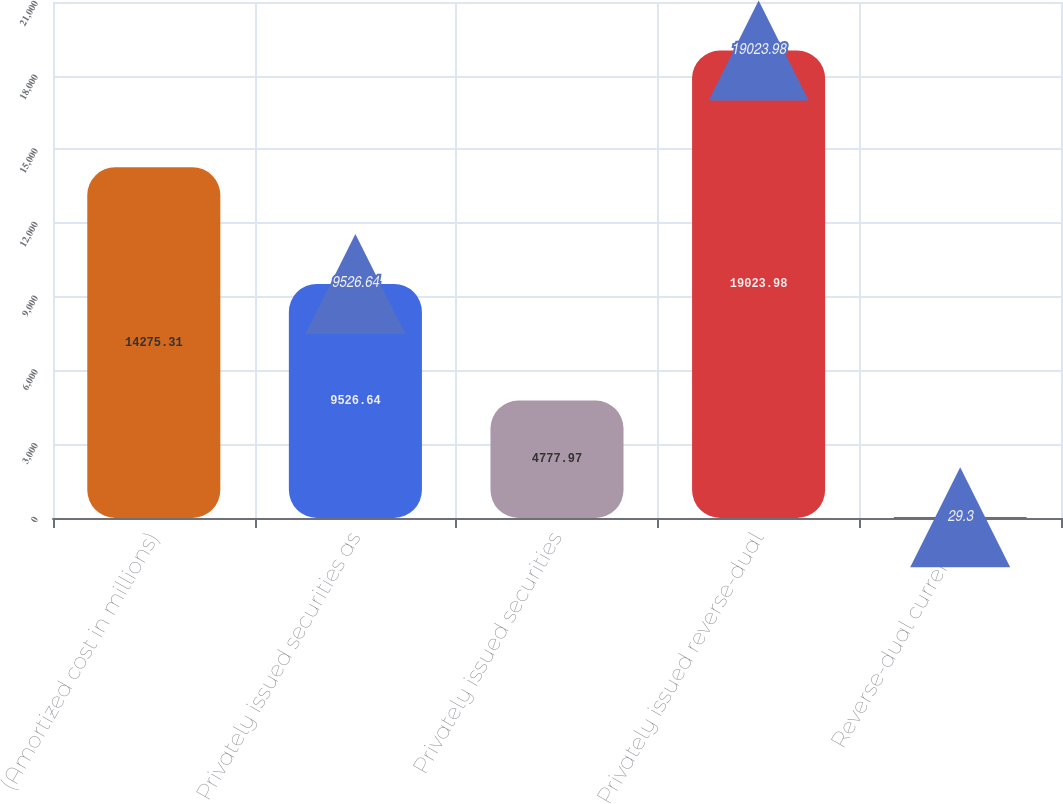Convert chart to OTSL. <chart><loc_0><loc_0><loc_500><loc_500><bar_chart><fcel>(Amortized cost in millions)<fcel>Privately issued securities as<fcel>Privately issued securities<fcel>Privately issued reverse-dual<fcel>Reverse-dual currency<nl><fcel>14275.3<fcel>9526.64<fcel>4777.97<fcel>19024<fcel>29.3<nl></chart> 